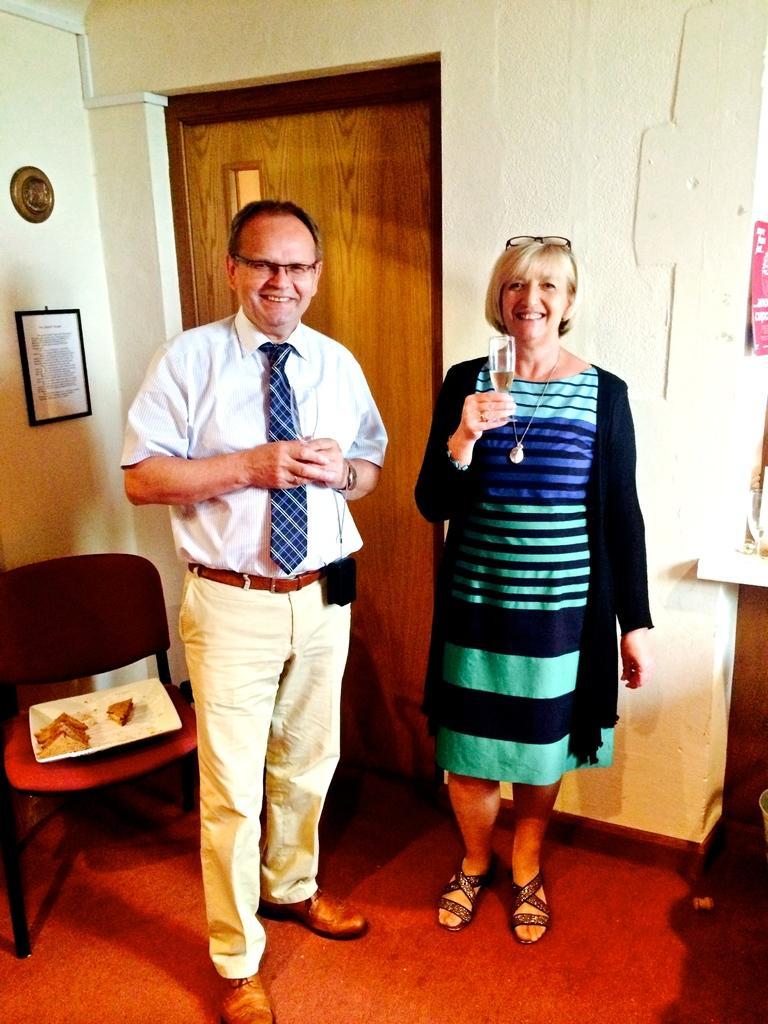How would you summarize this image in a sentence or two? In this picture there is a man and a woman in the center of the image and there is a door in the background area of the image, there is a chair on the left side of the image. 